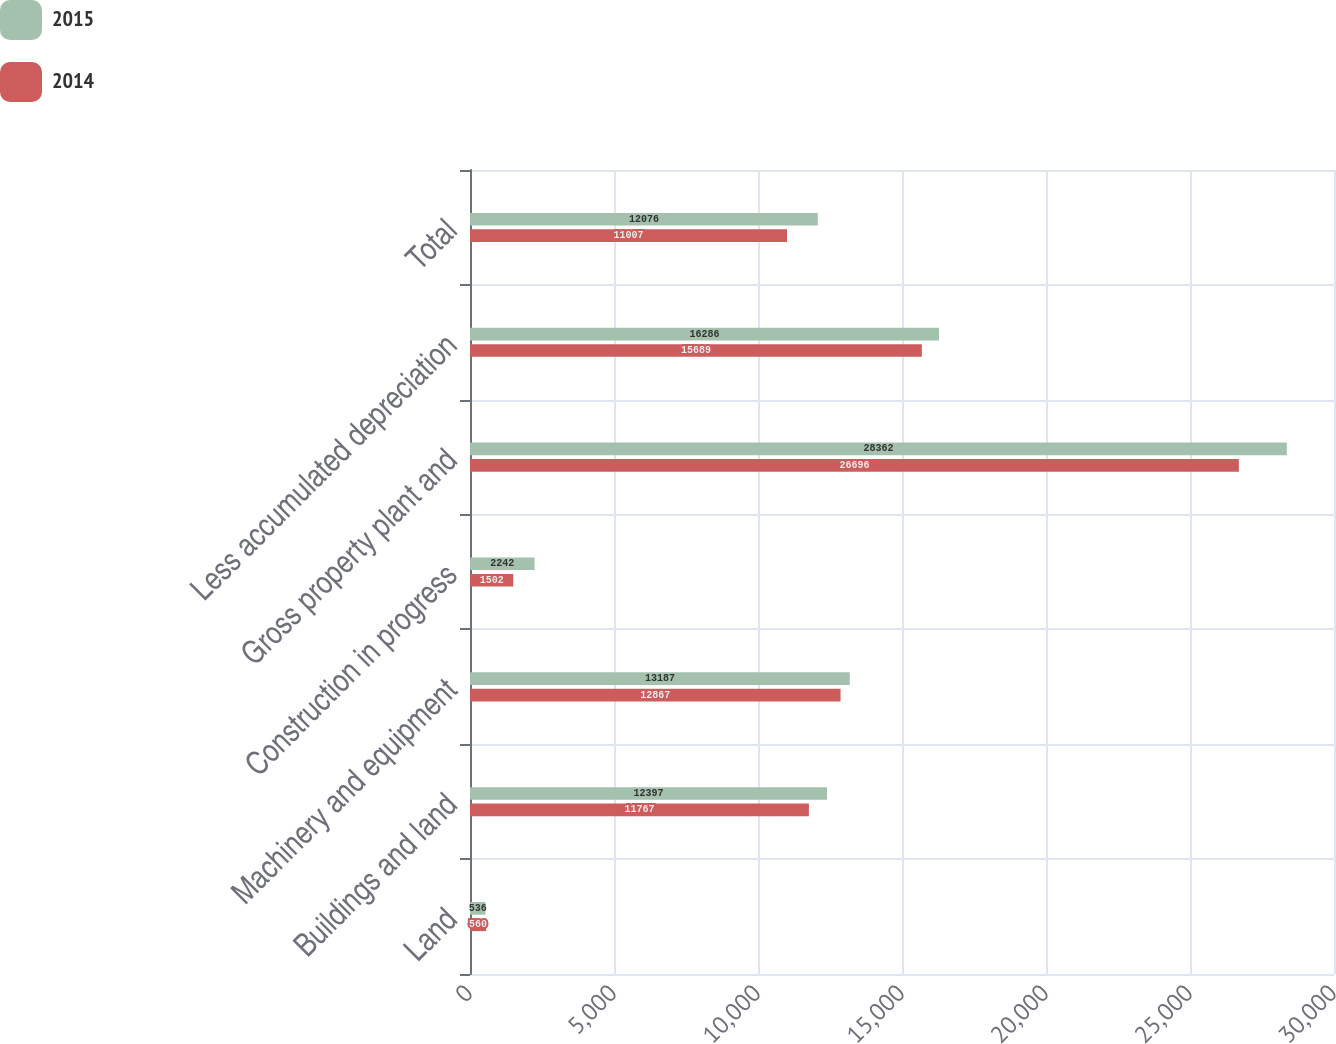Convert chart to OTSL. <chart><loc_0><loc_0><loc_500><loc_500><stacked_bar_chart><ecel><fcel>Land<fcel>Buildings and land<fcel>Machinery and equipment<fcel>Construction in progress<fcel>Gross property plant and<fcel>Less accumulated depreciation<fcel>Total<nl><fcel>2015<fcel>536<fcel>12397<fcel>13187<fcel>2242<fcel>28362<fcel>16286<fcel>12076<nl><fcel>2014<fcel>560<fcel>11767<fcel>12867<fcel>1502<fcel>26696<fcel>15689<fcel>11007<nl></chart> 